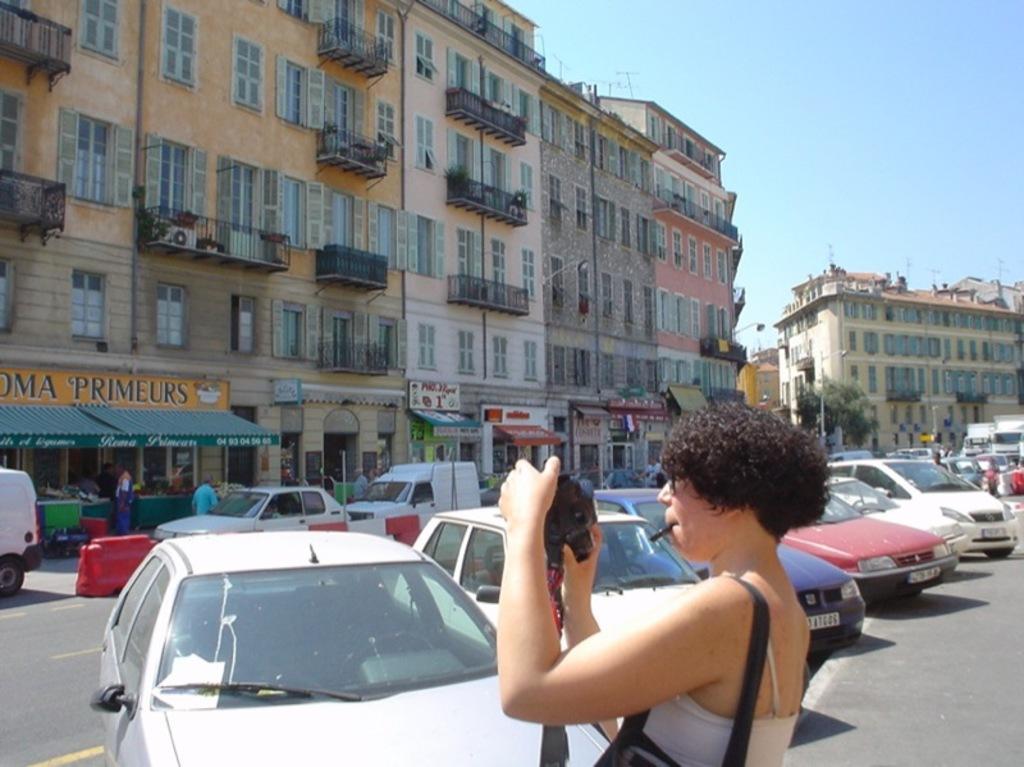Please provide a concise description of this image. In this image we can see a group of vehicles and some people on the ground. We can also see some buildings with windows, plants, the sign boards with some text on them and the sky. In the foreground we can see a woman standing holding a camera. 